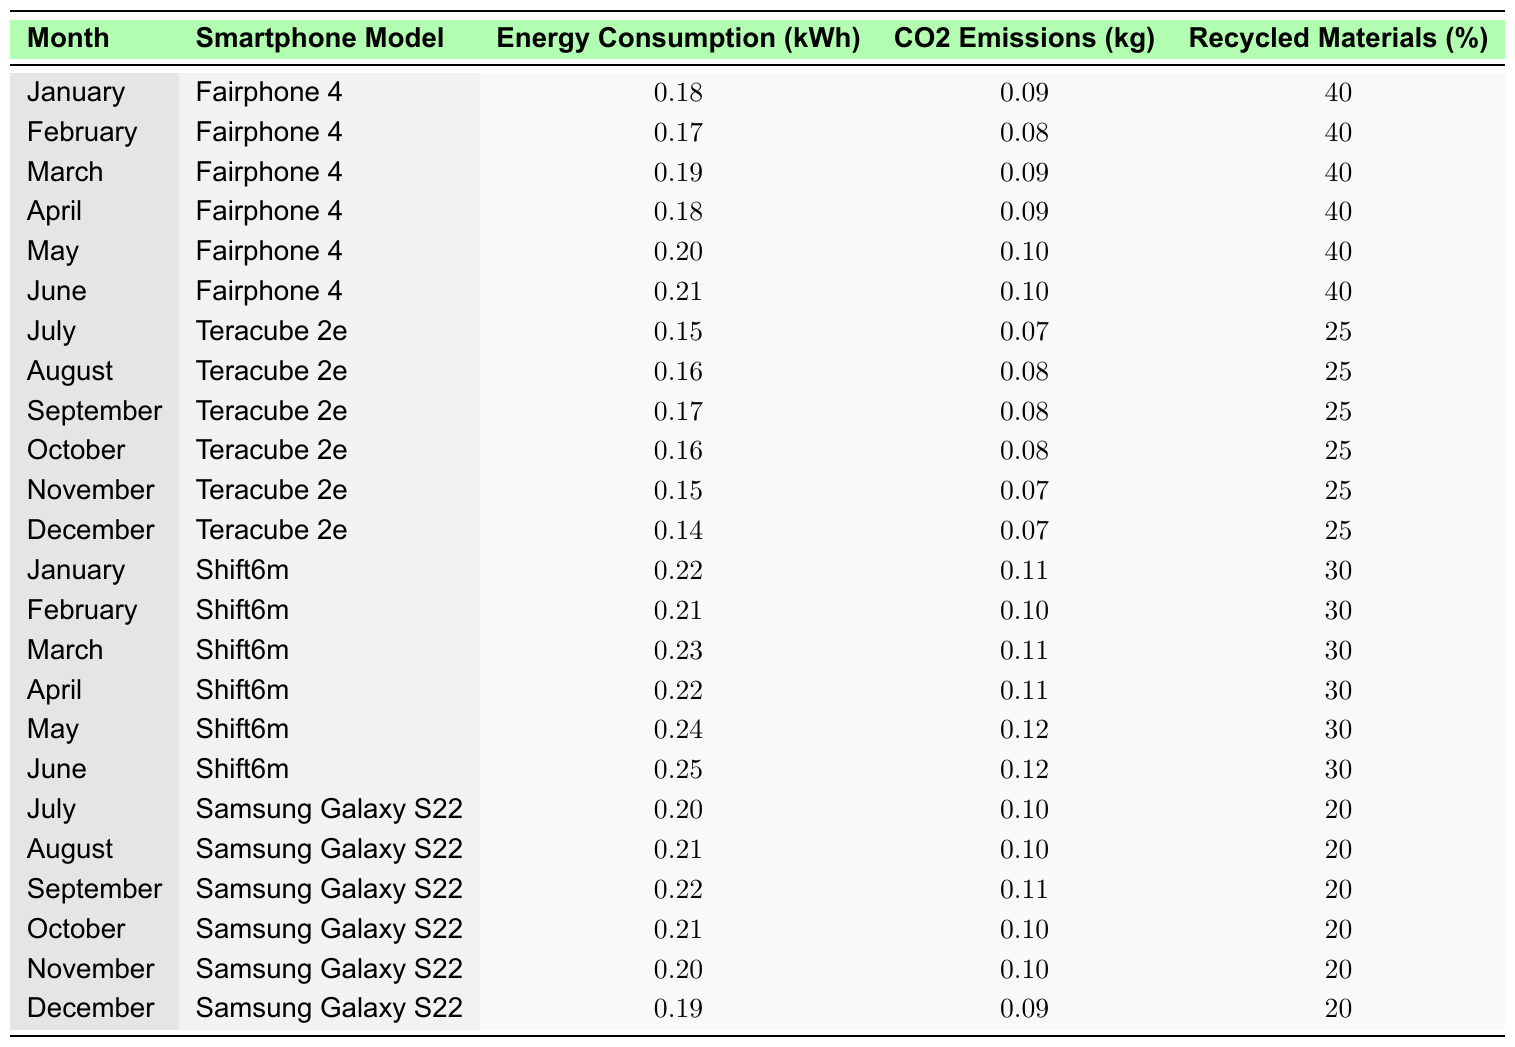What is the energy consumption of the Fairphone 4 in June? The table shows that in June, the Fairphone 4 has an energy consumption of 0.21 kWh.
Answer: 0.21 kWh Which smartphone model had the lowest energy consumption in December? In December, the energy consumption of the Teracube 2e is the lowest at 0.14 kWh compared to the other models listed for that month.
Answer: Teracube 2e What were the CO2 emissions of the Shift6m in March? The table indicates that the Shift6m had CO2 emissions of 0.11 kg in March.
Answer: 0.11 kg What is the average energy consumption of the Samsung Galaxy S22 from July to December? The energy consumption values for the Samsung Galaxy S22 from July to December are 0.20, 0.21, 0.22, 0.21, 0.20, and 0.19 kWh. The sum of these values is 1.23 kWh, and there are 6 months, so the average is 1.23 kWh / 6 = 0.205 kWh.
Answer: 0.205 kWh In which month did the Teracube 2e have the highest energy consumption? The highest energy consumption for the Teracube 2e is in September at 0.17 kWh, which can be compared with the other months listed for this model.
Answer: September Did the Fairphone 4 ever have higher CO2 emissions than the Shift6m? No, the CO2 emissions of the Fairphone 4 (0.10 kg max) are always lower than the Shift6m (0.12 kg max).
Answer: No What is the total recycled materials percentage for the Fairphone 4 over the six months recorded? The Fairphone 4 consistently has a recycled materials percentage of 40% for all six months, so 40% remains the total for all months, as it does not change.
Answer: 40% How does the average energy consumption of the Fairphone 4 compare to the Teracube 2e? For the Fairphone 4, the total energy consumption across the six months is 1.14 kWh (0.18 + 0.17 + 0.19 + 0.18 + 0.20 + 0.21), giving an average of 0.19 kWh. For the Teracube 2e, the total is 0.94 kWh (0.15 + 0.16 + 0.17 + 0.16 + 0.15 + 0.14), resulting in an average of 0.1567 kWh. Since 0.19 kWh is greater than 0.1567 kWh, the Fairphone 4 has a higher average energy consumption.
Answer: Fairphone 4 has higher average energy consumption What is the trend in energy consumption for the Shift6m from January to June? The energy consumption for the Shift6m starts at 0.22 kWh in January and increases progressively to 0.25 kWh in June. The values are: 0.22, 0.21, 0.23, 0.22, 0.24, 0.25, indicating a clear increasing trend.
Answer: Increasing trend 